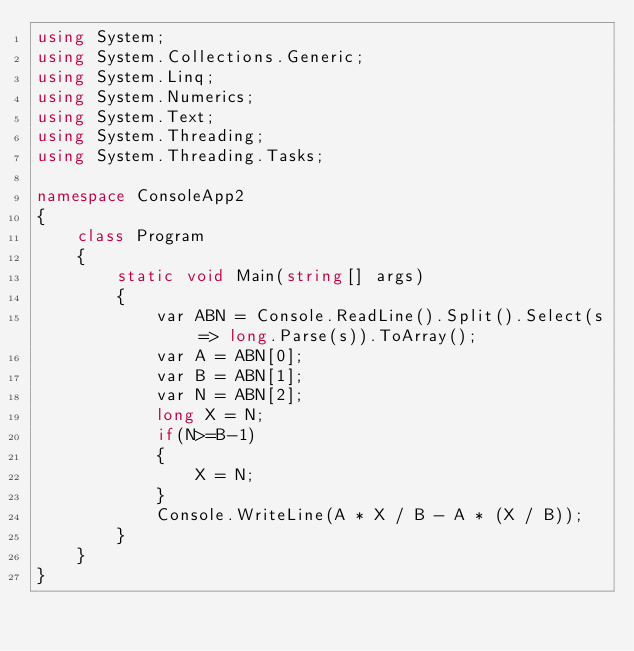Convert code to text. <code><loc_0><loc_0><loc_500><loc_500><_C#_>using System;
using System.Collections.Generic;
using System.Linq;
using System.Numerics;
using System.Text;
using System.Threading;
using System.Threading.Tasks;

namespace ConsoleApp2
{
    class Program
    {
        static void Main(string[] args)
        {
            var ABN = Console.ReadLine().Split().Select(s => long.Parse(s)).ToArray();
            var A = ABN[0];
            var B = ABN[1];
            var N = ABN[2];
            long X = N;
            if(N>=B-1)
            {
                X = N;
            }
            Console.WriteLine(A * X / B - A * (X / B));
        }
    }
}</code> 